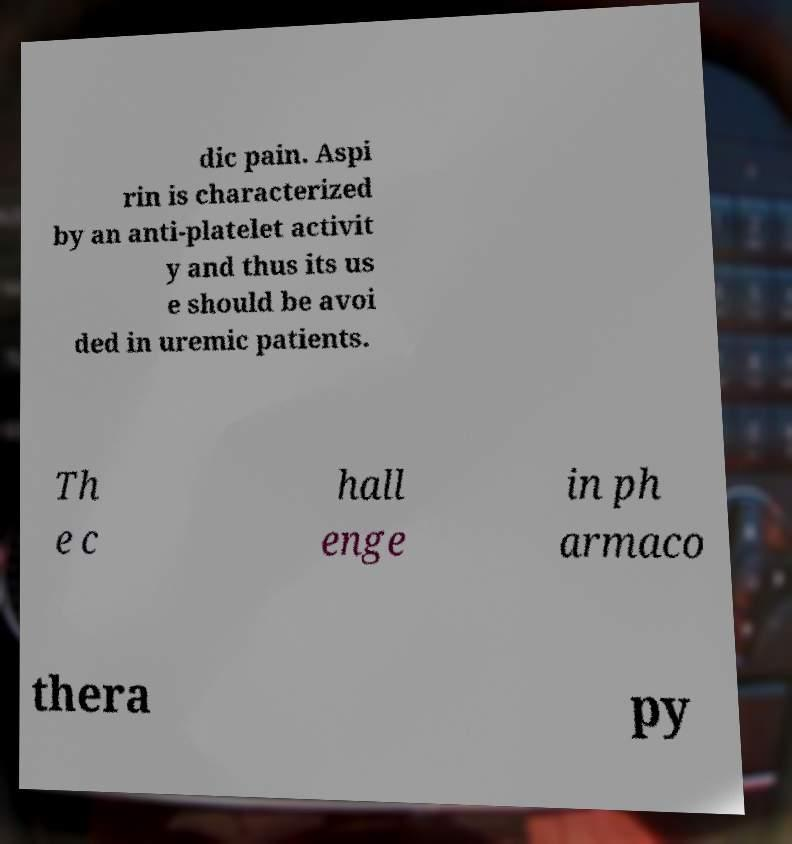Please read and relay the text visible in this image. What does it say? dic pain. Aspi rin is characterized by an anti-platelet activit y and thus its us e should be avoi ded in uremic patients. Th e c hall enge in ph armaco thera py 